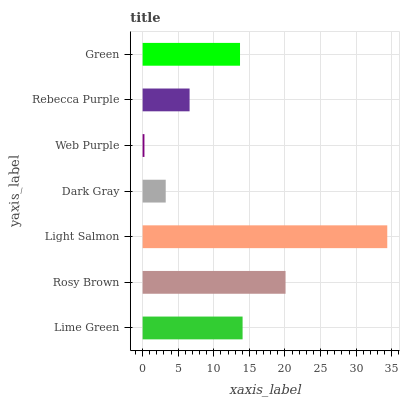Is Web Purple the minimum?
Answer yes or no. Yes. Is Light Salmon the maximum?
Answer yes or no. Yes. Is Rosy Brown the minimum?
Answer yes or no. No. Is Rosy Brown the maximum?
Answer yes or no. No. Is Rosy Brown greater than Lime Green?
Answer yes or no. Yes. Is Lime Green less than Rosy Brown?
Answer yes or no. Yes. Is Lime Green greater than Rosy Brown?
Answer yes or no. No. Is Rosy Brown less than Lime Green?
Answer yes or no. No. Is Green the high median?
Answer yes or no. Yes. Is Green the low median?
Answer yes or no. Yes. Is Web Purple the high median?
Answer yes or no. No. Is Rebecca Purple the low median?
Answer yes or no. No. 